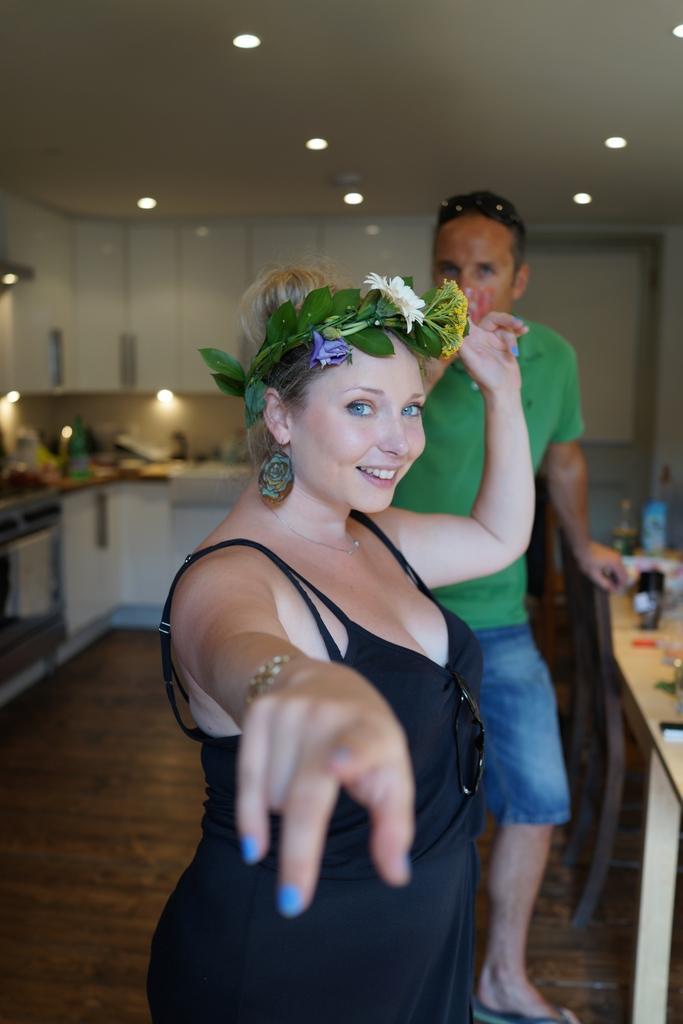Describe this image in one or two sentences. In this image we can see a woman and a man. She is smiling. There are tables, cupboards, bottles, towel, and few objects. In the background we can see lights and ceiling. 